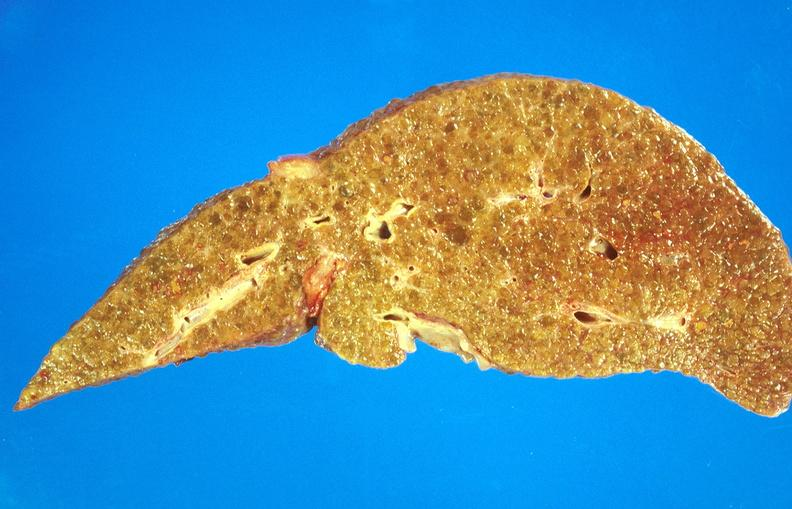s liver present?
Answer the question using a single word or phrase. Yes 